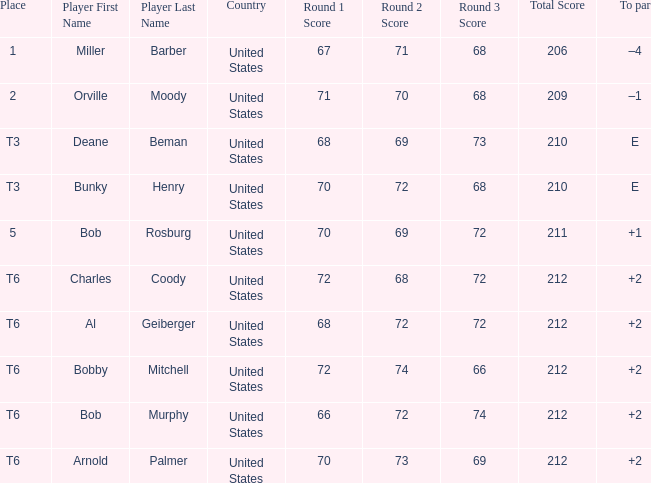What is the score of player bob rosburg? 70-69-72=211. 